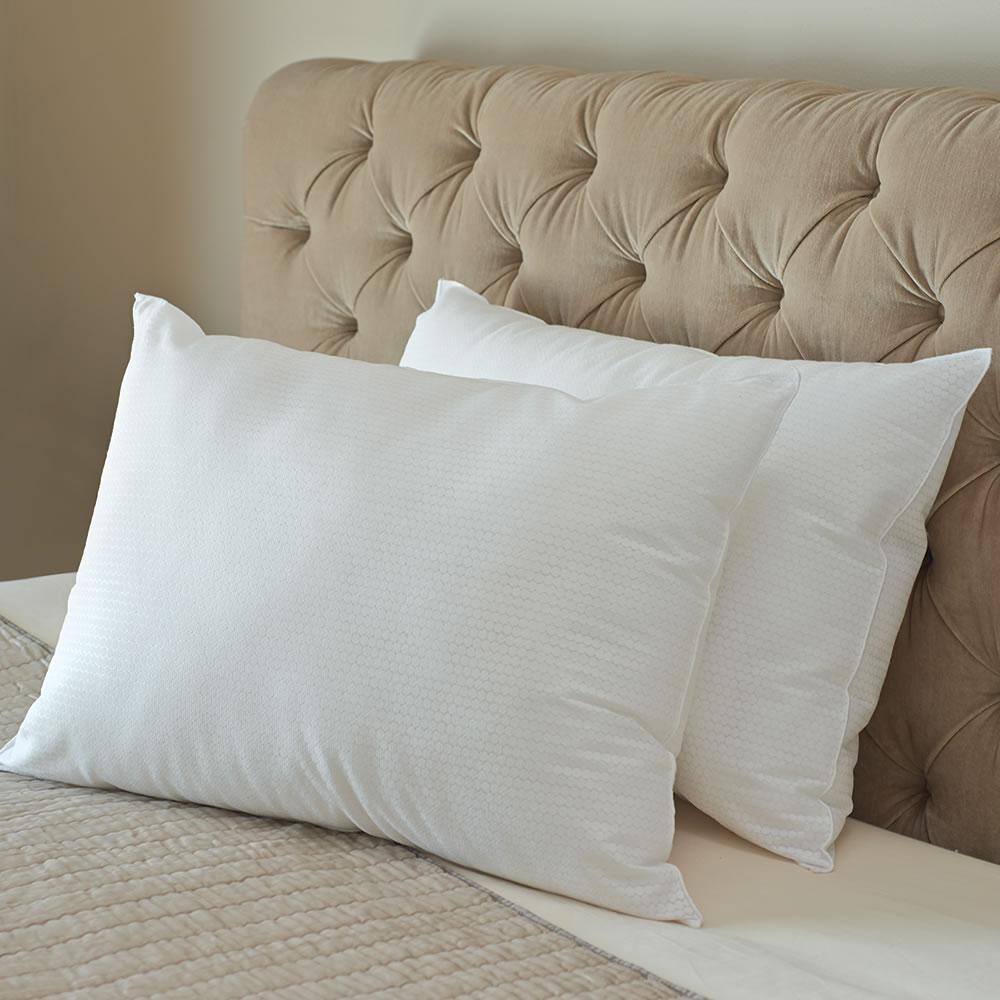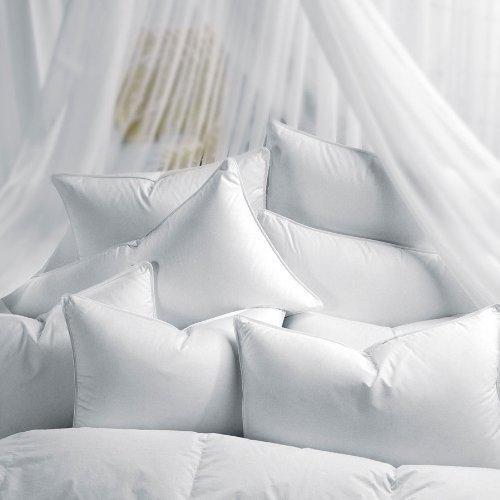The first image is the image on the left, the second image is the image on the right. Examine the images to the left and right. Is the description "The headboard in the image on the left is upholstered." accurate? Answer yes or no. Yes. 